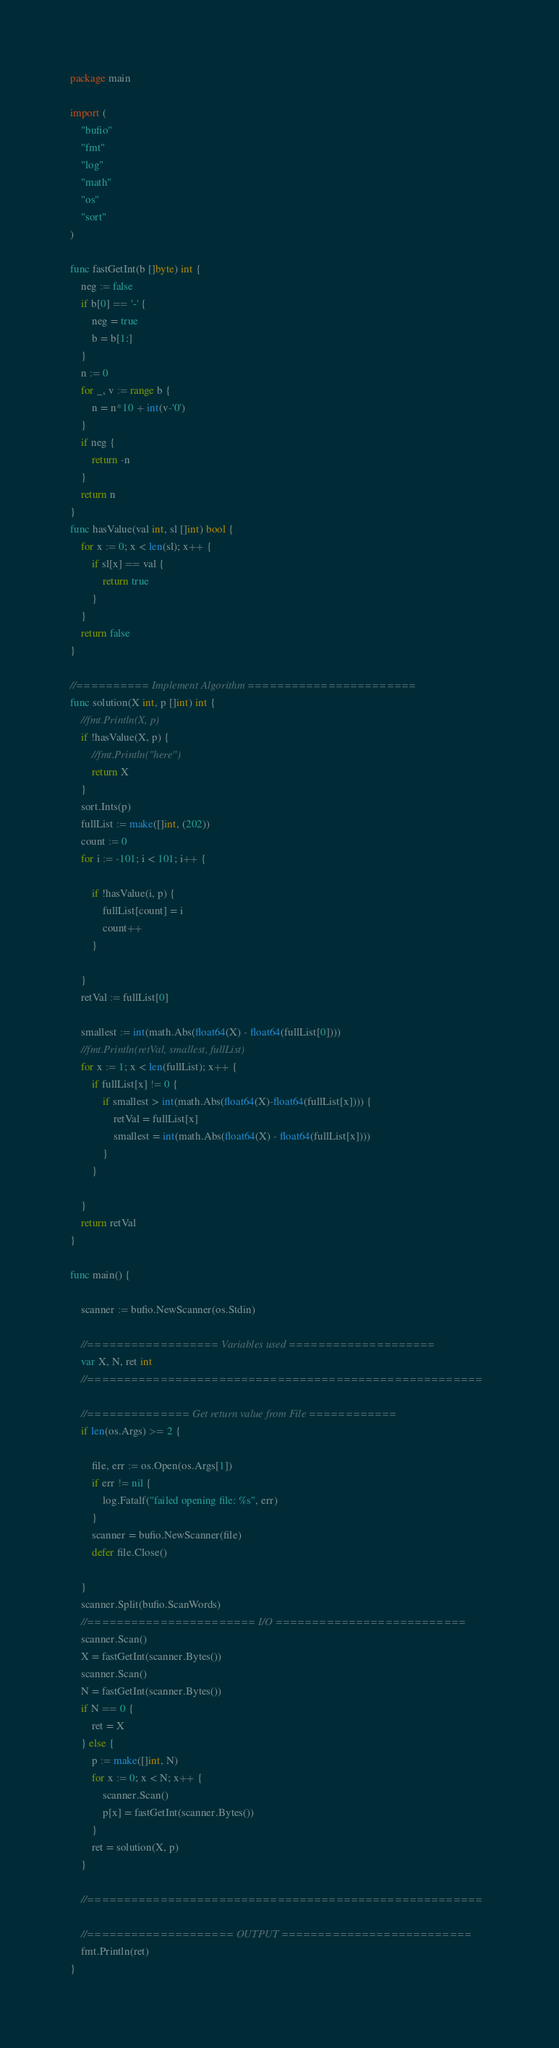Convert code to text. <code><loc_0><loc_0><loc_500><loc_500><_Go_>package main

import (
	"bufio"
	"fmt"
	"log"
	"math"
	"os"
	"sort"
)

func fastGetInt(b []byte) int {
	neg := false
	if b[0] == '-' {
		neg = true
		b = b[1:]
	}
	n := 0
	for _, v := range b {
		n = n*10 + int(v-'0')
	}
	if neg {
		return -n
	}
	return n
}
func hasValue(val int, sl []int) bool {
	for x := 0; x < len(sl); x++ {
		if sl[x] == val {
			return true
		}
	}
	return false
}

//========== Implement Algorithm =======================
func solution(X int, p []int) int {
	//fmt.Println(X, p)
	if !hasValue(X, p) {
		//fmt.Println("here")
		return X
	}
	sort.Ints(p)
	fullList := make([]int, (202))
	count := 0
	for i := -101; i < 101; i++ {

		if !hasValue(i, p) {
			fullList[count] = i
			count++
		}

	}
	retVal := fullList[0]

	smallest := int(math.Abs(float64(X) - float64(fullList[0])))
	//fmt.Println(retVal, smallest, fullList)
	for x := 1; x < len(fullList); x++ {
		if fullList[x] != 0 {
			if smallest > int(math.Abs(float64(X)-float64(fullList[x]))) {
				retVal = fullList[x]
				smallest = int(math.Abs(float64(X) - float64(fullList[x])))
			}
		}

	}
	return retVal
}

func main() {

	scanner := bufio.NewScanner(os.Stdin)

	//================== Variables used ====================
	var X, N, ret int
	//======================================================

	//============== Get return value from File ============
	if len(os.Args) >= 2 {

		file, err := os.Open(os.Args[1])
		if err != nil {
			log.Fatalf("failed opening file: %s", err)
		}
		scanner = bufio.NewScanner(file)
		defer file.Close()

	}
	scanner.Split(bufio.ScanWords)
	//======================= I/O ==========================
	scanner.Scan()
	X = fastGetInt(scanner.Bytes())
	scanner.Scan()
	N = fastGetInt(scanner.Bytes())
	if N == 0 {
		ret = X
	} else {
		p := make([]int, N)
		for x := 0; x < N; x++ {
			scanner.Scan()
			p[x] = fastGetInt(scanner.Bytes())
		}
		ret = solution(X, p)
	}

	//======================================================

	//==================== OUTPUT ==========================
	fmt.Println(ret)
}
</code> 